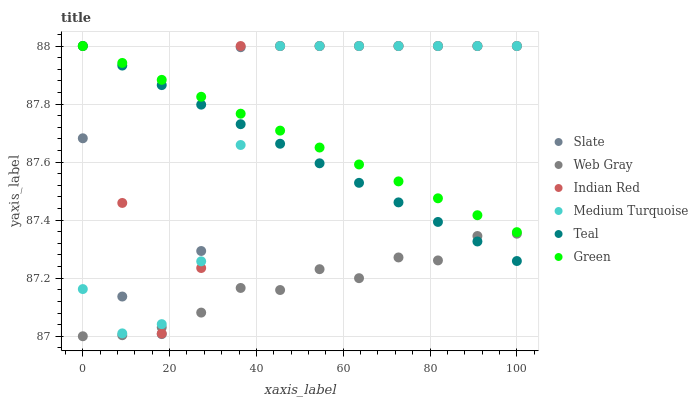Does Web Gray have the minimum area under the curve?
Answer yes or no. Yes. Does Indian Red have the maximum area under the curve?
Answer yes or no. Yes. Does Medium Turquoise have the minimum area under the curve?
Answer yes or no. No. Does Medium Turquoise have the maximum area under the curve?
Answer yes or no. No. Is Green the smoothest?
Answer yes or no. Yes. Is Indian Red the roughest?
Answer yes or no. Yes. Is Medium Turquoise the smoothest?
Answer yes or no. No. Is Medium Turquoise the roughest?
Answer yes or no. No. Does Web Gray have the lowest value?
Answer yes or no. Yes. Does Medium Turquoise have the lowest value?
Answer yes or no. No. Does Indian Red have the highest value?
Answer yes or no. Yes. Is Web Gray less than Green?
Answer yes or no. Yes. Is Medium Turquoise greater than Web Gray?
Answer yes or no. Yes. Does Indian Red intersect Medium Turquoise?
Answer yes or no. Yes. Is Indian Red less than Medium Turquoise?
Answer yes or no. No. Is Indian Red greater than Medium Turquoise?
Answer yes or no. No. Does Web Gray intersect Green?
Answer yes or no. No. 